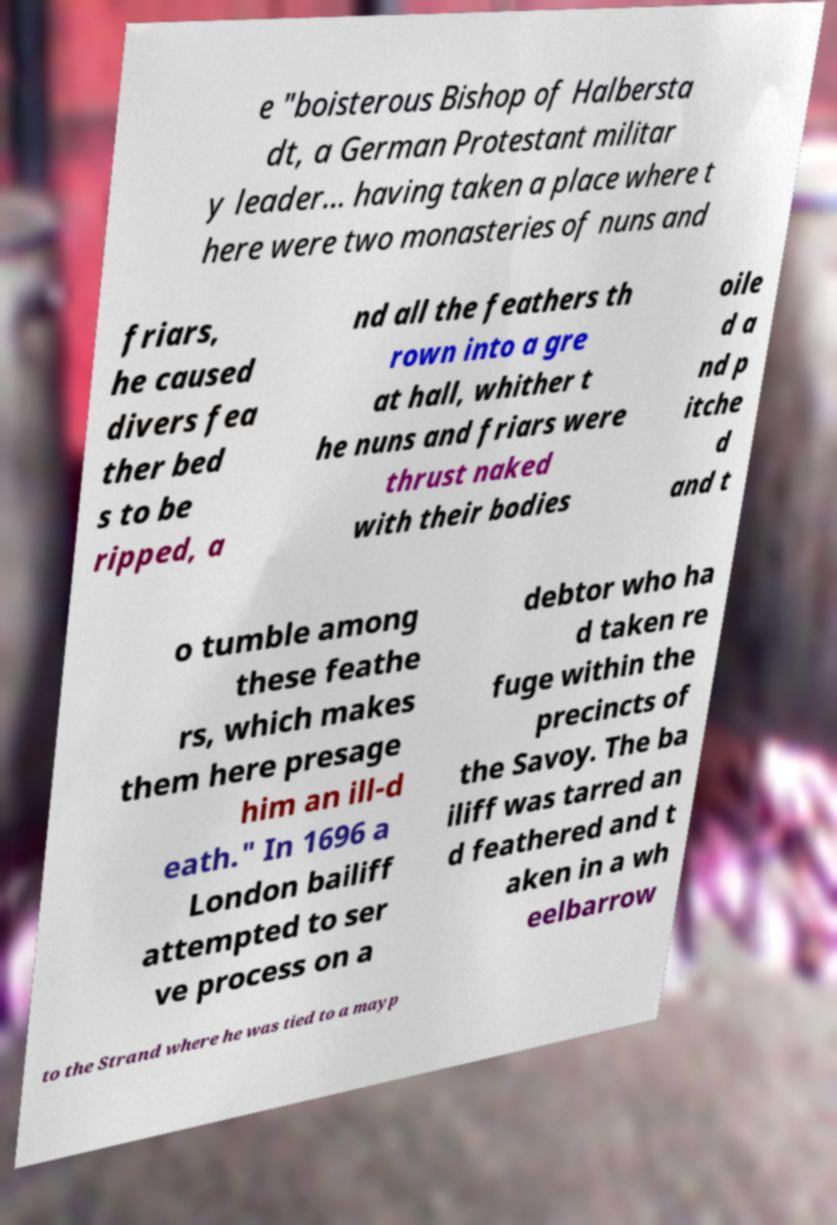There's text embedded in this image that I need extracted. Can you transcribe it verbatim? e "boisterous Bishop of Halbersta dt, a German Protestant militar y leader... having taken a place where t here were two monasteries of nuns and friars, he caused divers fea ther bed s to be ripped, a nd all the feathers th rown into a gre at hall, whither t he nuns and friars were thrust naked with their bodies oile d a nd p itche d and t o tumble among these feathe rs, which makes them here presage him an ill-d eath." In 1696 a London bailiff attempted to ser ve process on a debtor who ha d taken re fuge within the precincts of the Savoy. The ba iliff was tarred an d feathered and t aken in a wh eelbarrow to the Strand where he was tied to a mayp 